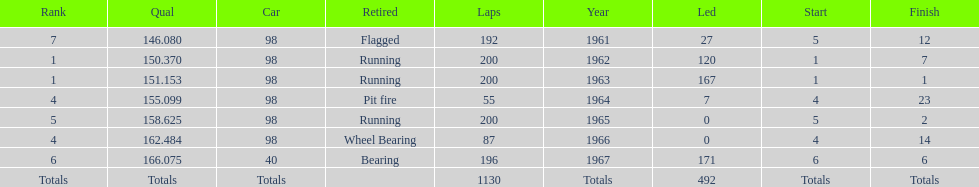In which years did he lead the race the least? 1965, 1966. 